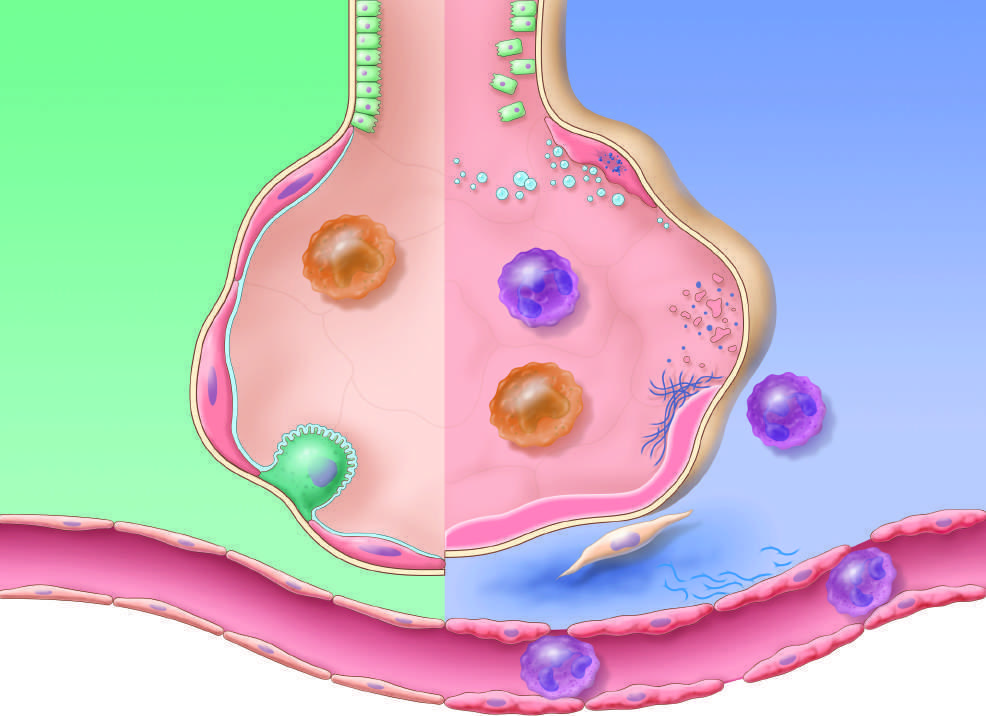do the dark green polypeptides stimulate fibroblast growth and collagen deposition associated with the healing phase of injury?
Answer the question using a single word or phrase. No 